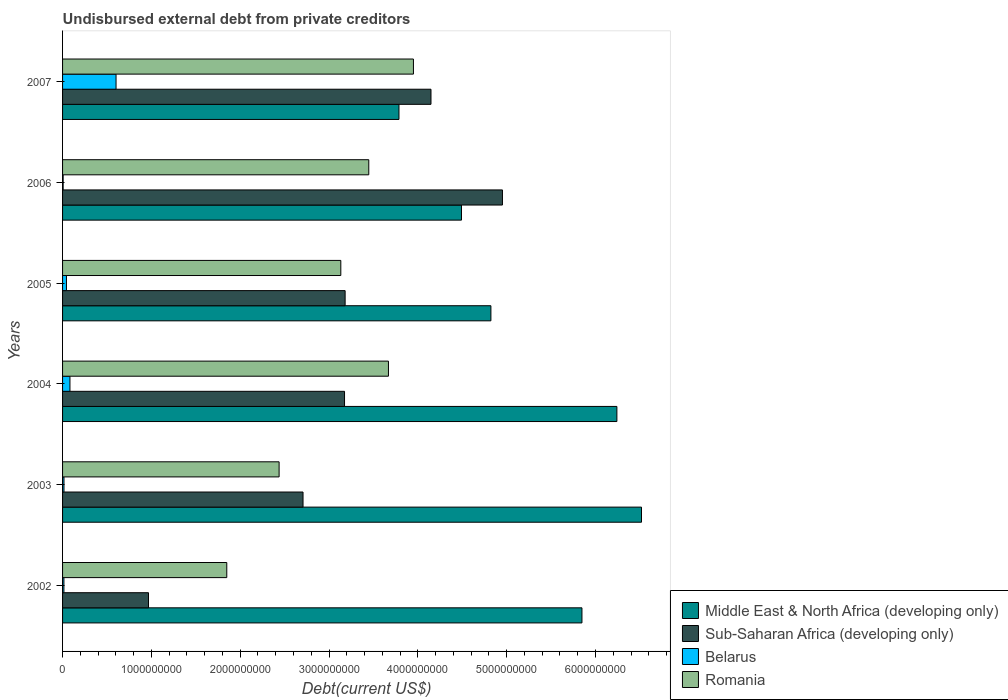How many different coloured bars are there?
Provide a succinct answer. 4. Are the number of bars on each tick of the Y-axis equal?
Provide a short and direct response. Yes. How many bars are there on the 6th tick from the top?
Your answer should be very brief. 4. What is the total debt in Romania in 2006?
Make the answer very short. 3.45e+09. Across all years, what is the maximum total debt in Romania?
Your answer should be compact. 3.95e+09. Across all years, what is the minimum total debt in Romania?
Offer a terse response. 1.85e+09. In which year was the total debt in Middle East & North Africa (developing only) maximum?
Your response must be concise. 2003. In which year was the total debt in Middle East & North Africa (developing only) minimum?
Your answer should be compact. 2007. What is the total total debt in Belarus in the graph?
Give a very brief answer. 7.67e+08. What is the difference between the total debt in Belarus in 2004 and that in 2006?
Provide a succinct answer. 7.65e+07. What is the difference between the total debt in Romania in 2004 and the total debt in Middle East & North Africa (developing only) in 2002?
Offer a very short reply. -2.18e+09. What is the average total debt in Middle East & North Africa (developing only) per year?
Your answer should be very brief. 5.28e+09. In the year 2002, what is the difference between the total debt in Romania and total debt in Middle East & North Africa (developing only)?
Ensure brevity in your answer.  -4.00e+09. What is the ratio of the total debt in Romania in 2003 to that in 2004?
Make the answer very short. 0.66. Is the difference between the total debt in Romania in 2002 and 2003 greater than the difference between the total debt in Middle East & North Africa (developing only) in 2002 and 2003?
Offer a terse response. Yes. What is the difference between the highest and the second highest total debt in Belarus?
Provide a succinct answer. 5.19e+08. What is the difference between the highest and the lowest total debt in Romania?
Make the answer very short. 2.10e+09. In how many years, is the total debt in Middle East & North Africa (developing only) greater than the average total debt in Middle East & North Africa (developing only) taken over all years?
Provide a succinct answer. 3. Is it the case that in every year, the sum of the total debt in Belarus and total debt in Middle East & North Africa (developing only) is greater than the sum of total debt in Romania and total debt in Sub-Saharan Africa (developing only)?
Your response must be concise. No. What does the 2nd bar from the top in 2007 represents?
Offer a very short reply. Belarus. What does the 2nd bar from the bottom in 2003 represents?
Make the answer very short. Sub-Saharan Africa (developing only). How many bars are there?
Provide a succinct answer. 24. Are all the bars in the graph horizontal?
Keep it short and to the point. Yes. Are the values on the major ticks of X-axis written in scientific E-notation?
Keep it short and to the point. No. Does the graph contain any zero values?
Make the answer very short. No. Does the graph contain grids?
Provide a succinct answer. No. Where does the legend appear in the graph?
Offer a terse response. Bottom right. How many legend labels are there?
Provide a short and direct response. 4. How are the legend labels stacked?
Keep it short and to the point. Vertical. What is the title of the graph?
Keep it short and to the point. Undisbursed external debt from private creditors. What is the label or title of the X-axis?
Provide a short and direct response. Debt(current US$). What is the Debt(current US$) in Middle East & North Africa (developing only) in 2002?
Make the answer very short. 5.85e+09. What is the Debt(current US$) of Sub-Saharan Africa (developing only) in 2002?
Provide a short and direct response. 9.67e+08. What is the Debt(current US$) in Belarus in 2002?
Keep it short and to the point. 1.54e+07. What is the Debt(current US$) of Romania in 2002?
Give a very brief answer. 1.85e+09. What is the Debt(current US$) in Middle East & North Africa (developing only) in 2003?
Provide a short and direct response. 6.52e+09. What is the Debt(current US$) of Sub-Saharan Africa (developing only) in 2003?
Give a very brief answer. 2.71e+09. What is the Debt(current US$) in Belarus in 2003?
Make the answer very short. 1.59e+07. What is the Debt(current US$) in Romania in 2003?
Offer a very short reply. 2.44e+09. What is the Debt(current US$) of Middle East & North Africa (developing only) in 2004?
Your answer should be very brief. 6.24e+09. What is the Debt(current US$) of Sub-Saharan Africa (developing only) in 2004?
Your answer should be very brief. 3.17e+09. What is the Debt(current US$) in Belarus in 2004?
Your answer should be compact. 8.32e+07. What is the Debt(current US$) in Romania in 2004?
Offer a terse response. 3.67e+09. What is the Debt(current US$) of Middle East & North Africa (developing only) in 2005?
Ensure brevity in your answer.  4.82e+09. What is the Debt(current US$) of Sub-Saharan Africa (developing only) in 2005?
Give a very brief answer. 3.18e+09. What is the Debt(current US$) in Belarus in 2005?
Provide a succinct answer. 4.38e+07. What is the Debt(current US$) of Romania in 2005?
Provide a short and direct response. 3.13e+09. What is the Debt(current US$) of Middle East & North Africa (developing only) in 2006?
Provide a short and direct response. 4.49e+09. What is the Debt(current US$) in Sub-Saharan Africa (developing only) in 2006?
Provide a succinct answer. 4.95e+09. What is the Debt(current US$) of Belarus in 2006?
Ensure brevity in your answer.  6.63e+06. What is the Debt(current US$) of Romania in 2006?
Give a very brief answer. 3.45e+09. What is the Debt(current US$) in Middle East & North Africa (developing only) in 2007?
Provide a short and direct response. 3.79e+09. What is the Debt(current US$) in Sub-Saharan Africa (developing only) in 2007?
Offer a very short reply. 4.15e+09. What is the Debt(current US$) of Belarus in 2007?
Provide a short and direct response. 6.02e+08. What is the Debt(current US$) in Romania in 2007?
Offer a very short reply. 3.95e+09. Across all years, what is the maximum Debt(current US$) in Middle East & North Africa (developing only)?
Provide a short and direct response. 6.52e+09. Across all years, what is the maximum Debt(current US$) of Sub-Saharan Africa (developing only)?
Offer a very short reply. 4.95e+09. Across all years, what is the maximum Debt(current US$) of Belarus?
Provide a short and direct response. 6.02e+08. Across all years, what is the maximum Debt(current US$) in Romania?
Give a very brief answer. 3.95e+09. Across all years, what is the minimum Debt(current US$) of Middle East & North Africa (developing only)?
Your response must be concise. 3.79e+09. Across all years, what is the minimum Debt(current US$) of Sub-Saharan Africa (developing only)?
Keep it short and to the point. 9.67e+08. Across all years, what is the minimum Debt(current US$) of Belarus?
Give a very brief answer. 6.63e+06. Across all years, what is the minimum Debt(current US$) of Romania?
Give a very brief answer. 1.85e+09. What is the total Debt(current US$) of Middle East & North Africa (developing only) in the graph?
Offer a very short reply. 3.17e+1. What is the total Debt(current US$) of Sub-Saharan Africa (developing only) in the graph?
Give a very brief answer. 1.91e+1. What is the total Debt(current US$) in Belarus in the graph?
Your answer should be compact. 7.67e+08. What is the total Debt(current US$) in Romania in the graph?
Your answer should be compact. 1.85e+1. What is the difference between the Debt(current US$) in Middle East & North Africa (developing only) in 2002 and that in 2003?
Your answer should be very brief. -6.70e+08. What is the difference between the Debt(current US$) of Sub-Saharan Africa (developing only) in 2002 and that in 2003?
Make the answer very short. -1.74e+09. What is the difference between the Debt(current US$) of Belarus in 2002 and that in 2003?
Keep it short and to the point. -5.75e+05. What is the difference between the Debt(current US$) of Romania in 2002 and that in 2003?
Give a very brief answer. -5.89e+08. What is the difference between the Debt(current US$) of Middle East & North Africa (developing only) in 2002 and that in 2004?
Keep it short and to the point. -3.93e+08. What is the difference between the Debt(current US$) in Sub-Saharan Africa (developing only) in 2002 and that in 2004?
Offer a very short reply. -2.21e+09. What is the difference between the Debt(current US$) in Belarus in 2002 and that in 2004?
Provide a short and direct response. -6.78e+07. What is the difference between the Debt(current US$) of Romania in 2002 and that in 2004?
Your response must be concise. -1.82e+09. What is the difference between the Debt(current US$) of Middle East & North Africa (developing only) in 2002 and that in 2005?
Offer a very short reply. 1.03e+09. What is the difference between the Debt(current US$) of Sub-Saharan Africa (developing only) in 2002 and that in 2005?
Your answer should be compact. -2.21e+09. What is the difference between the Debt(current US$) in Belarus in 2002 and that in 2005?
Your response must be concise. -2.85e+07. What is the difference between the Debt(current US$) of Romania in 2002 and that in 2005?
Offer a terse response. -1.28e+09. What is the difference between the Debt(current US$) in Middle East & North Africa (developing only) in 2002 and that in 2006?
Ensure brevity in your answer.  1.36e+09. What is the difference between the Debt(current US$) in Sub-Saharan Africa (developing only) in 2002 and that in 2006?
Give a very brief answer. -3.99e+09. What is the difference between the Debt(current US$) in Belarus in 2002 and that in 2006?
Offer a terse response. 8.72e+06. What is the difference between the Debt(current US$) of Romania in 2002 and that in 2006?
Ensure brevity in your answer.  -1.60e+09. What is the difference between the Debt(current US$) of Middle East & North Africa (developing only) in 2002 and that in 2007?
Keep it short and to the point. 2.06e+09. What is the difference between the Debt(current US$) in Sub-Saharan Africa (developing only) in 2002 and that in 2007?
Provide a succinct answer. -3.18e+09. What is the difference between the Debt(current US$) of Belarus in 2002 and that in 2007?
Your response must be concise. -5.87e+08. What is the difference between the Debt(current US$) in Romania in 2002 and that in 2007?
Provide a succinct answer. -2.10e+09. What is the difference between the Debt(current US$) in Middle East & North Africa (developing only) in 2003 and that in 2004?
Your answer should be compact. 2.77e+08. What is the difference between the Debt(current US$) in Sub-Saharan Africa (developing only) in 2003 and that in 2004?
Give a very brief answer. -4.67e+08. What is the difference between the Debt(current US$) of Belarus in 2003 and that in 2004?
Your answer should be very brief. -6.72e+07. What is the difference between the Debt(current US$) of Romania in 2003 and that in 2004?
Keep it short and to the point. -1.23e+09. What is the difference between the Debt(current US$) in Middle East & North Africa (developing only) in 2003 and that in 2005?
Your answer should be compact. 1.70e+09. What is the difference between the Debt(current US$) in Sub-Saharan Africa (developing only) in 2003 and that in 2005?
Give a very brief answer. -4.74e+08. What is the difference between the Debt(current US$) in Belarus in 2003 and that in 2005?
Keep it short and to the point. -2.79e+07. What is the difference between the Debt(current US$) of Romania in 2003 and that in 2005?
Offer a very short reply. -6.95e+08. What is the difference between the Debt(current US$) of Middle East & North Africa (developing only) in 2003 and that in 2006?
Keep it short and to the point. 2.03e+09. What is the difference between the Debt(current US$) of Sub-Saharan Africa (developing only) in 2003 and that in 2006?
Provide a short and direct response. -2.25e+09. What is the difference between the Debt(current US$) of Belarus in 2003 and that in 2006?
Offer a terse response. 9.30e+06. What is the difference between the Debt(current US$) in Romania in 2003 and that in 2006?
Your answer should be very brief. -1.01e+09. What is the difference between the Debt(current US$) in Middle East & North Africa (developing only) in 2003 and that in 2007?
Give a very brief answer. 2.73e+09. What is the difference between the Debt(current US$) of Sub-Saharan Africa (developing only) in 2003 and that in 2007?
Offer a very short reply. -1.44e+09. What is the difference between the Debt(current US$) in Belarus in 2003 and that in 2007?
Offer a very short reply. -5.86e+08. What is the difference between the Debt(current US$) in Romania in 2003 and that in 2007?
Your answer should be compact. -1.51e+09. What is the difference between the Debt(current US$) of Middle East & North Africa (developing only) in 2004 and that in 2005?
Provide a short and direct response. 1.42e+09. What is the difference between the Debt(current US$) in Sub-Saharan Africa (developing only) in 2004 and that in 2005?
Your answer should be very brief. -6.60e+06. What is the difference between the Debt(current US$) of Belarus in 2004 and that in 2005?
Keep it short and to the point. 3.93e+07. What is the difference between the Debt(current US$) of Romania in 2004 and that in 2005?
Your answer should be compact. 5.36e+08. What is the difference between the Debt(current US$) of Middle East & North Africa (developing only) in 2004 and that in 2006?
Ensure brevity in your answer.  1.75e+09. What is the difference between the Debt(current US$) of Sub-Saharan Africa (developing only) in 2004 and that in 2006?
Make the answer very short. -1.78e+09. What is the difference between the Debt(current US$) of Belarus in 2004 and that in 2006?
Provide a succinct answer. 7.65e+07. What is the difference between the Debt(current US$) of Romania in 2004 and that in 2006?
Provide a short and direct response. 2.21e+08. What is the difference between the Debt(current US$) in Middle East & North Africa (developing only) in 2004 and that in 2007?
Provide a succinct answer. 2.45e+09. What is the difference between the Debt(current US$) of Sub-Saharan Africa (developing only) in 2004 and that in 2007?
Keep it short and to the point. -9.73e+08. What is the difference between the Debt(current US$) of Belarus in 2004 and that in 2007?
Make the answer very short. -5.19e+08. What is the difference between the Debt(current US$) of Romania in 2004 and that in 2007?
Make the answer very short. -2.81e+08. What is the difference between the Debt(current US$) of Middle East & North Africa (developing only) in 2005 and that in 2006?
Your response must be concise. 3.31e+08. What is the difference between the Debt(current US$) in Sub-Saharan Africa (developing only) in 2005 and that in 2006?
Keep it short and to the point. -1.77e+09. What is the difference between the Debt(current US$) in Belarus in 2005 and that in 2006?
Ensure brevity in your answer.  3.72e+07. What is the difference between the Debt(current US$) of Romania in 2005 and that in 2006?
Offer a terse response. -3.15e+08. What is the difference between the Debt(current US$) of Middle East & North Africa (developing only) in 2005 and that in 2007?
Offer a terse response. 1.04e+09. What is the difference between the Debt(current US$) in Sub-Saharan Africa (developing only) in 2005 and that in 2007?
Ensure brevity in your answer.  -9.67e+08. What is the difference between the Debt(current US$) of Belarus in 2005 and that in 2007?
Your answer should be very brief. -5.58e+08. What is the difference between the Debt(current US$) in Romania in 2005 and that in 2007?
Your response must be concise. -8.18e+08. What is the difference between the Debt(current US$) in Middle East & North Africa (developing only) in 2006 and that in 2007?
Ensure brevity in your answer.  7.04e+08. What is the difference between the Debt(current US$) of Sub-Saharan Africa (developing only) in 2006 and that in 2007?
Give a very brief answer. 8.05e+08. What is the difference between the Debt(current US$) in Belarus in 2006 and that in 2007?
Make the answer very short. -5.95e+08. What is the difference between the Debt(current US$) of Romania in 2006 and that in 2007?
Keep it short and to the point. -5.03e+08. What is the difference between the Debt(current US$) of Middle East & North Africa (developing only) in 2002 and the Debt(current US$) of Sub-Saharan Africa (developing only) in 2003?
Make the answer very short. 3.14e+09. What is the difference between the Debt(current US$) of Middle East & North Africa (developing only) in 2002 and the Debt(current US$) of Belarus in 2003?
Keep it short and to the point. 5.83e+09. What is the difference between the Debt(current US$) of Middle East & North Africa (developing only) in 2002 and the Debt(current US$) of Romania in 2003?
Make the answer very short. 3.41e+09. What is the difference between the Debt(current US$) in Sub-Saharan Africa (developing only) in 2002 and the Debt(current US$) in Belarus in 2003?
Ensure brevity in your answer.  9.52e+08. What is the difference between the Debt(current US$) of Sub-Saharan Africa (developing only) in 2002 and the Debt(current US$) of Romania in 2003?
Provide a succinct answer. -1.47e+09. What is the difference between the Debt(current US$) in Belarus in 2002 and the Debt(current US$) in Romania in 2003?
Provide a succinct answer. -2.42e+09. What is the difference between the Debt(current US$) in Middle East & North Africa (developing only) in 2002 and the Debt(current US$) in Sub-Saharan Africa (developing only) in 2004?
Ensure brevity in your answer.  2.67e+09. What is the difference between the Debt(current US$) of Middle East & North Africa (developing only) in 2002 and the Debt(current US$) of Belarus in 2004?
Offer a terse response. 5.76e+09. What is the difference between the Debt(current US$) of Middle East & North Africa (developing only) in 2002 and the Debt(current US$) of Romania in 2004?
Give a very brief answer. 2.18e+09. What is the difference between the Debt(current US$) of Sub-Saharan Africa (developing only) in 2002 and the Debt(current US$) of Belarus in 2004?
Make the answer very short. 8.84e+08. What is the difference between the Debt(current US$) in Sub-Saharan Africa (developing only) in 2002 and the Debt(current US$) in Romania in 2004?
Offer a terse response. -2.70e+09. What is the difference between the Debt(current US$) of Belarus in 2002 and the Debt(current US$) of Romania in 2004?
Offer a very short reply. -3.65e+09. What is the difference between the Debt(current US$) in Middle East & North Africa (developing only) in 2002 and the Debt(current US$) in Sub-Saharan Africa (developing only) in 2005?
Provide a short and direct response. 2.67e+09. What is the difference between the Debt(current US$) of Middle East & North Africa (developing only) in 2002 and the Debt(current US$) of Belarus in 2005?
Keep it short and to the point. 5.80e+09. What is the difference between the Debt(current US$) of Middle East & North Africa (developing only) in 2002 and the Debt(current US$) of Romania in 2005?
Provide a succinct answer. 2.72e+09. What is the difference between the Debt(current US$) of Sub-Saharan Africa (developing only) in 2002 and the Debt(current US$) of Belarus in 2005?
Make the answer very short. 9.24e+08. What is the difference between the Debt(current US$) in Sub-Saharan Africa (developing only) in 2002 and the Debt(current US$) in Romania in 2005?
Give a very brief answer. -2.17e+09. What is the difference between the Debt(current US$) of Belarus in 2002 and the Debt(current US$) of Romania in 2005?
Your answer should be compact. -3.12e+09. What is the difference between the Debt(current US$) of Middle East & North Africa (developing only) in 2002 and the Debt(current US$) of Sub-Saharan Africa (developing only) in 2006?
Offer a very short reply. 8.95e+08. What is the difference between the Debt(current US$) in Middle East & North Africa (developing only) in 2002 and the Debt(current US$) in Belarus in 2006?
Your response must be concise. 5.84e+09. What is the difference between the Debt(current US$) in Middle East & North Africa (developing only) in 2002 and the Debt(current US$) in Romania in 2006?
Offer a terse response. 2.40e+09. What is the difference between the Debt(current US$) of Sub-Saharan Africa (developing only) in 2002 and the Debt(current US$) of Belarus in 2006?
Your answer should be compact. 9.61e+08. What is the difference between the Debt(current US$) of Sub-Saharan Africa (developing only) in 2002 and the Debt(current US$) of Romania in 2006?
Offer a terse response. -2.48e+09. What is the difference between the Debt(current US$) in Belarus in 2002 and the Debt(current US$) in Romania in 2006?
Make the answer very short. -3.43e+09. What is the difference between the Debt(current US$) of Middle East & North Africa (developing only) in 2002 and the Debt(current US$) of Sub-Saharan Africa (developing only) in 2007?
Keep it short and to the point. 1.70e+09. What is the difference between the Debt(current US$) in Middle East & North Africa (developing only) in 2002 and the Debt(current US$) in Belarus in 2007?
Ensure brevity in your answer.  5.25e+09. What is the difference between the Debt(current US$) of Middle East & North Africa (developing only) in 2002 and the Debt(current US$) of Romania in 2007?
Make the answer very short. 1.90e+09. What is the difference between the Debt(current US$) of Sub-Saharan Africa (developing only) in 2002 and the Debt(current US$) of Belarus in 2007?
Provide a succinct answer. 3.65e+08. What is the difference between the Debt(current US$) in Sub-Saharan Africa (developing only) in 2002 and the Debt(current US$) in Romania in 2007?
Your response must be concise. -2.98e+09. What is the difference between the Debt(current US$) in Belarus in 2002 and the Debt(current US$) in Romania in 2007?
Your answer should be very brief. -3.94e+09. What is the difference between the Debt(current US$) in Middle East & North Africa (developing only) in 2003 and the Debt(current US$) in Sub-Saharan Africa (developing only) in 2004?
Provide a short and direct response. 3.34e+09. What is the difference between the Debt(current US$) of Middle East & North Africa (developing only) in 2003 and the Debt(current US$) of Belarus in 2004?
Offer a terse response. 6.44e+09. What is the difference between the Debt(current US$) in Middle East & North Africa (developing only) in 2003 and the Debt(current US$) in Romania in 2004?
Your answer should be compact. 2.85e+09. What is the difference between the Debt(current US$) in Sub-Saharan Africa (developing only) in 2003 and the Debt(current US$) in Belarus in 2004?
Make the answer very short. 2.62e+09. What is the difference between the Debt(current US$) in Sub-Saharan Africa (developing only) in 2003 and the Debt(current US$) in Romania in 2004?
Your answer should be compact. -9.62e+08. What is the difference between the Debt(current US$) of Belarus in 2003 and the Debt(current US$) of Romania in 2004?
Provide a succinct answer. -3.65e+09. What is the difference between the Debt(current US$) of Middle East & North Africa (developing only) in 2003 and the Debt(current US$) of Sub-Saharan Africa (developing only) in 2005?
Your answer should be compact. 3.34e+09. What is the difference between the Debt(current US$) in Middle East & North Africa (developing only) in 2003 and the Debt(current US$) in Belarus in 2005?
Your response must be concise. 6.47e+09. What is the difference between the Debt(current US$) in Middle East & North Africa (developing only) in 2003 and the Debt(current US$) in Romania in 2005?
Offer a very short reply. 3.39e+09. What is the difference between the Debt(current US$) of Sub-Saharan Africa (developing only) in 2003 and the Debt(current US$) of Belarus in 2005?
Offer a terse response. 2.66e+09. What is the difference between the Debt(current US$) in Sub-Saharan Africa (developing only) in 2003 and the Debt(current US$) in Romania in 2005?
Ensure brevity in your answer.  -4.25e+08. What is the difference between the Debt(current US$) of Belarus in 2003 and the Debt(current US$) of Romania in 2005?
Offer a very short reply. -3.12e+09. What is the difference between the Debt(current US$) in Middle East & North Africa (developing only) in 2003 and the Debt(current US$) in Sub-Saharan Africa (developing only) in 2006?
Your response must be concise. 1.57e+09. What is the difference between the Debt(current US$) in Middle East & North Africa (developing only) in 2003 and the Debt(current US$) in Belarus in 2006?
Keep it short and to the point. 6.51e+09. What is the difference between the Debt(current US$) in Middle East & North Africa (developing only) in 2003 and the Debt(current US$) in Romania in 2006?
Ensure brevity in your answer.  3.07e+09. What is the difference between the Debt(current US$) of Sub-Saharan Africa (developing only) in 2003 and the Debt(current US$) of Belarus in 2006?
Your response must be concise. 2.70e+09. What is the difference between the Debt(current US$) of Sub-Saharan Africa (developing only) in 2003 and the Debt(current US$) of Romania in 2006?
Offer a very short reply. -7.40e+08. What is the difference between the Debt(current US$) in Belarus in 2003 and the Debt(current US$) in Romania in 2006?
Offer a terse response. -3.43e+09. What is the difference between the Debt(current US$) in Middle East & North Africa (developing only) in 2003 and the Debt(current US$) in Sub-Saharan Africa (developing only) in 2007?
Make the answer very short. 2.37e+09. What is the difference between the Debt(current US$) of Middle East & North Africa (developing only) in 2003 and the Debt(current US$) of Belarus in 2007?
Provide a succinct answer. 5.92e+09. What is the difference between the Debt(current US$) in Middle East & North Africa (developing only) in 2003 and the Debt(current US$) in Romania in 2007?
Keep it short and to the point. 2.57e+09. What is the difference between the Debt(current US$) of Sub-Saharan Africa (developing only) in 2003 and the Debt(current US$) of Belarus in 2007?
Make the answer very short. 2.11e+09. What is the difference between the Debt(current US$) of Sub-Saharan Africa (developing only) in 2003 and the Debt(current US$) of Romania in 2007?
Provide a short and direct response. -1.24e+09. What is the difference between the Debt(current US$) of Belarus in 2003 and the Debt(current US$) of Romania in 2007?
Make the answer very short. -3.93e+09. What is the difference between the Debt(current US$) of Middle East & North Africa (developing only) in 2004 and the Debt(current US$) of Sub-Saharan Africa (developing only) in 2005?
Provide a short and direct response. 3.06e+09. What is the difference between the Debt(current US$) of Middle East & North Africa (developing only) in 2004 and the Debt(current US$) of Belarus in 2005?
Your answer should be compact. 6.20e+09. What is the difference between the Debt(current US$) in Middle East & North Africa (developing only) in 2004 and the Debt(current US$) in Romania in 2005?
Offer a terse response. 3.11e+09. What is the difference between the Debt(current US$) of Sub-Saharan Africa (developing only) in 2004 and the Debt(current US$) of Belarus in 2005?
Give a very brief answer. 3.13e+09. What is the difference between the Debt(current US$) of Sub-Saharan Africa (developing only) in 2004 and the Debt(current US$) of Romania in 2005?
Give a very brief answer. 4.19e+07. What is the difference between the Debt(current US$) of Belarus in 2004 and the Debt(current US$) of Romania in 2005?
Make the answer very short. -3.05e+09. What is the difference between the Debt(current US$) in Middle East & North Africa (developing only) in 2004 and the Debt(current US$) in Sub-Saharan Africa (developing only) in 2006?
Offer a terse response. 1.29e+09. What is the difference between the Debt(current US$) in Middle East & North Africa (developing only) in 2004 and the Debt(current US$) in Belarus in 2006?
Provide a short and direct response. 6.23e+09. What is the difference between the Debt(current US$) in Middle East & North Africa (developing only) in 2004 and the Debt(current US$) in Romania in 2006?
Give a very brief answer. 2.79e+09. What is the difference between the Debt(current US$) in Sub-Saharan Africa (developing only) in 2004 and the Debt(current US$) in Belarus in 2006?
Your answer should be compact. 3.17e+09. What is the difference between the Debt(current US$) of Sub-Saharan Africa (developing only) in 2004 and the Debt(current US$) of Romania in 2006?
Provide a short and direct response. -2.73e+08. What is the difference between the Debt(current US$) of Belarus in 2004 and the Debt(current US$) of Romania in 2006?
Give a very brief answer. -3.36e+09. What is the difference between the Debt(current US$) in Middle East & North Africa (developing only) in 2004 and the Debt(current US$) in Sub-Saharan Africa (developing only) in 2007?
Keep it short and to the point. 2.09e+09. What is the difference between the Debt(current US$) of Middle East & North Africa (developing only) in 2004 and the Debt(current US$) of Belarus in 2007?
Your answer should be very brief. 5.64e+09. What is the difference between the Debt(current US$) of Middle East & North Africa (developing only) in 2004 and the Debt(current US$) of Romania in 2007?
Provide a short and direct response. 2.29e+09. What is the difference between the Debt(current US$) in Sub-Saharan Africa (developing only) in 2004 and the Debt(current US$) in Belarus in 2007?
Offer a terse response. 2.57e+09. What is the difference between the Debt(current US$) in Sub-Saharan Africa (developing only) in 2004 and the Debt(current US$) in Romania in 2007?
Make the answer very short. -7.76e+08. What is the difference between the Debt(current US$) in Belarus in 2004 and the Debt(current US$) in Romania in 2007?
Offer a terse response. -3.87e+09. What is the difference between the Debt(current US$) in Middle East & North Africa (developing only) in 2005 and the Debt(current US$) in Sub-Saharan Africa (developing only) in 2006?
Provide a short and direct response. -1.30e+08. What is the difference between the Debt(current US$) of Middle East & North Africa (developing only) in 2005 and the Debt(current US$) of Belarus in 2006?
Your answer should be very brief. 4.82e+09. What is the difference between the Debt(current US$) of Middle East & North Africa (developing only) in 2005 and the Debt(current US$) of Romania in 2006?
Your answer should be very brief. 1.38e+09. What is the difference between the Debt(current US$) in Sub-Saharan Africa (developing only) in 2005 and the Debt(current US$) in Belarus in 2006?
Ensure brevity in your answer.  3.17e+09. What is the difference between the Debt(current US$) in Sub-Saharan Africa (developing only) in 2005 and the Debt(current US$) in Romania in 2006?
Provide a succinct answer. -2.66e+08. What is the difference between the Debt(current US$) in Belarus in 2005 and the Debt(current US$) in Romania in 2006?
Offer a very short reply. -3.40e+09. What is the difference between the Debt(current US$) of Middle East & North Africa (developing only) in 2005 and the Debt(current US$) of Sub-Saharan Africa (developing only) in 2007?
Make the answer very short. 6.75e+08. What is the difference between the Debt(current US$) of Middle East & North Africa (developing only) in 2005 and the Debt(current US$) of Belarus in 2007?
Give a very brief answer. 4.22e+09. What is the difference between the Debt(current US$) in Middle East & North Africa (developing only) in 2005 and the Debt(current US$) in Romania in 2007?
Offer a very short reply. 8.72e+08. What is the difference between the Debt(current US$) in Sub-Saharan Africa (developing only) in 2005 and the Debt(current US$) in Belarus in 2007?
Provide a short and direct response. 2.58e+09. What is the difference between the Debt(current US$) in Sub-Saharan Africa (developing only) in 2005 and the Debt(current US$) in Romania in 2007?
Offer a very short reply. -7.69e+08. What is the difference between the Debt(current US$) of Belarus in 2005 and the Debt(current US$) of Romania in 2007?
Provide a succinct answer. -3.91e+09. What is the difference between the Debt(current US$) in Middle East & North Africa (developing only) in 2006 and the Debt(current US$) in Sub-Saharan Africa (developing only) in 2007?
Give a very brief answer. 3.43e+08. What is the difference between the Debt(current US$) in Middle East & North Africa (developing only) in 2006 and the Debt(current US$) in Belarus in 2007?
Give a very brief answer. 3.89e+09. What is the difference between the Debt(current US$) of Middle East & North Africa (developing only) in 2006 and the Debt(current US$) of Romania in 2007?
Your answer should be compact. 5.41e+08. What is the difference between the Debt(current US$) in Sub-Saharan Africa (developing only) in 2006 and the Debt(current US$) in Belarus in 2007?
Offer a very short reply. 4.35e+09. What is the difference between the Debt(current US$) of Sub-Saharan Africa (developing only) in 2006 and the Debt(current US$) of Romania in 2007?
Your answer should be very brief. 1.00e+09. What is the difference between the Debt(current US$) in Belarus in 2006 and the Debt(current US$) in Romania in 2007?
Provide a succinct answer. -3.94e+09. What is the average Debt(current US$) of Middle East & North Africa (developing only) per year?
Your response must be concise. 5.28e+09. What is the average Debt(current US$) in Sub-Saharan Africa (developing only) per year?
Offer a very short reply. 3.19e+09. What is the average Debt(current US$) of Belarus per year?
Give a very brief answer. 1.28e+08. What is the average Debt(current US$) in Romania per year?
Make the answer very short. 3.08e+09. In the year 2002, what is the difference between the Debt(current US$) of Middle East & North Africa (developing only) and Debt(current US$) of Sub-Saharan Africa (developing only)?
Provide a short and direct response. 4.88e+09. In the year 2002, what is the difference between the Debt(current US$) of Middle East & North Africa (developing only) and Debt(current US$) of Belarus?
Ensure brevity in your answer.  5.83e+09. In the year 2002, what is the difference between the Debt(current US$) in Middle East & North Africa (developing only) and Debt(current US$) in Romania?
Your answer should be very brief. 4.00e+09. In the year 2002, what is the difference between the Debt(current US$) of Sub-Saharan Africa (developing only) and Debt(current US$) of Belarus?
Provide a succinct answer. 9.52e+08. In the year 2002, what is the difference between the Debt(current US$) in Sub-Saharan Africa (developing only) and Debt(current US$) in Romania?
Offer a terse response. -8.81e+08. In the year 2002, what is the difference between the Debt(current US$) of Belarus and Debt(current US$) of Romania?
Give a very brief answer. -1.83e+09. In the year 2003, what is the difference between the Debt(current US$) of Middle East & North Africa (developing only) and Debt(current US$) of Sub-Saharan Africa (developing only)?
Offer a terse response. 3.81e+09. In the year 2003, what is the difference between the Debt(current US$) of Middle East & North Africa (developing only) and Debt(current US$) of Belarus?
Your response must be concise. 6.50e+09. In the year 2003, what is the difference between the Debt(current US$) in Middle East & North Africa (developing only) and Debt(current US$) in Romania?
Make the answer very short. 4.08e+09. In the year 2003, what is the difference between the Debt(current US$) of Sub-Saharan Africa (developing only) and Debt(current US$) of Belarus?
Provide a short and direct response. 2.69e+09. In the year 2003, what is the difference between the Debt(current US$) of Sub-Saharan Africa (developing only) and Debt(current US$) of Romania?
Your answer should be very brief. 2.69e+08. In the year 2003, what is the difference between the Debt(current US$) of Belarus and Debt(current US$) of Romania?
Ensure brevity in your answer.  -2.42e+09. In the year 2004, what is the difference between the Debt(current US$) of Middle East & North Africa (developing only) and Debt(current US$) of Sub-Saharan Africa (developing only)?
Your answer should be compact. 3.07e+09. In the year 2004, what is the difference between the Debt(current US$) in Middle East & North Africa (developing only) and Debt(current US$) in Belarus?
Make the answer very short. 6.16e+09. In the year 2004, what is the difference between the Debt(current US$) in Middle East & North Africa (developing only) and Debt(current US$) in Romania?
Offer a terse response. 2.57e+09. In the year 2004, what is the difference between the Debt(current US$) in Sub-Saharan Africa (developing only) and Debt(current US$) in Belarus?
Your response must be concise. 3.09e+09. In the year 2004, what is the difference between the Debt(current US$) in Sub-Saharan Africa (developing only) and Debt(current US$) in Romania?
Give a very brief answer. -4.94e+08. In the year 2004, what is the difference between the Debt(current US$) in Belarus and Debt(current US$) in Romania?
Make the answer very short. -3.59e+09. In the year 2005, what is the difference between the Debt(current US$) of Middle East & North Africa (developing only) and Debt(current US$) of Sub-Saharan Africa (developing only)?
Give a very brief answer. 1.64e+09. In the year 2005, what is the difference between the Debt(current US$) in Middle East & North Africa (developing only) and Debt(current US$) in Belarus?
Give a very brief answer. 4.78e+09. In the year 2005, what is the difference between the Debt(current US$) of Middle East & North Africa (developing only) and Debt(current US$) of Romania?
Your response must be concise. 1.69e+09. In the year 2005, what is the difference between the Debt(current US$) in Sub-Saharan Africa (developing only) and Debt(current US$) in Belarus?
Make the answer very short. 3.14e+09. In the year 2005, what is the difference between the Debt(current US$) in Sub-Saharan Africa (developing only) and Debt(current US$) in Romania?
Offer a terse response. 4.85e+07. In the year 2005, what is the difference between the Debt(current US$) in Belarus and Debt(current US$) in Romania?
Provide a succinct answer. -3.09e+09. In the year 2006, what is the difference between the Debt(current US$) of Middle East & North Africa (developing only) and Debt(current US$) of Sub-Saharan Africa (developing only)?
Provide a short and direct response. -4.61e+08. In the year 2006, what is the difference between the Debt(current US$) in Middle East & North Africa (developing only) and Debt(current US$) in Belarus?
Ensure brevity in your answer.  4.48e+09. In the year 2006, what is the difference between the Debt(current US$) of Middle East & North Africa (developing only) and Debt(current US$) of Romania?
Give a very brief answer. 1.04e+09. In the year 2006, what is the difference between the Debt(current US$) of Sub-Saharan Africa (developing only) and Debt(current US$) of Belarus?
Provide a short and direct response. 4.95e+09. In the year 2006, what is the difference between the Debt(current US$) in Sub-Saharan Africa (developing only) and Debt(current US$) in Romania?
Make the answer very short. 1.50e+09. In the year 2006, what is the difference between the Debt(current US$) in Belarus and Debt(current US$) in Romania?
Offer a terse response. -3.44e+09. In the year 2007, what is the difference between the Debt(current US$) of Middle East & North Africa (developing only) and Debt(current US$) of Sub-Saharan Africa (developing only)?
Make the answer very short. -3.60e+08. In the year 2007, what is the difference between the Debt(current US$) in Middle East & North Africa (developing only) and Debt(current US$) in Belarus?
Offer a very short reply. 3.19e+09. In the year 2007, what is the difference between the Debt(current US$) in Middle East & North Africa (developing only) and Debt(current US$) in Romania?
Provide a short and direct response. -1.63e+08. In the year 2007, what is the difference between the Debt(current US$) in Sub-Saharan Africa (developing only) and Debt(current US$) in Belarus?
Provide a succinct answer. 3.55e+09. In the year 2007, what is the difference between the Debt(current US$) in Sub-Saharan Africa (developing only) and Debt(current US$) in Romania?
Offer a terse response. 1.97e+08. In the year 2007, what is the difference between the Debt(current US$) of Belarus and Debt(current US$) of Romania?
Ensure brevity in your answer.  -3.35e+09. What is the ratio of the Debt(current US$) in Middle East & North Africa (developing only) in 2002 to that in 2003?
Offer a terse response. 0.9. What is the ratio of the Debt(current US$) in Sub-Saharan Africa (developing only) in 2002 to that in 2003?
Make the answer very short. 0.36. What is the ratio of the Debt(current US$) in Belarus in 2002 to that in 2003?
Offer a terse response. 0.96. What is the ratio of the Debt(current US$) in Romania in 2002 to that in 2003?
Make the answer very short. 0.76. What is the ratio of the Debt(current US$) in Middle East & North Africa (developing only) in 2002 to that in 2004?
Your response must be concise. 0.94. What is the ratio of the Debt(current US$) in Sub-Saharan Africa (developing only) in 2002 to that in 2004?
Provide a short and direct response. 0.3. What is the ratio of the Debt(current US$) of Belarus in 2002 to that in 2004?
Your response must be concise. 0.18. What is the ratio of the Debt(current US$) of Romania in 2002 to that in 2004?
Offer a very short reply. 0.5. What is the ratio of the Debt(current US$) of Middle East & North Africa (developing only) in 2002 to that in 2005?
Offer a terse response. 1.21. What is the ratio of the Debt(current US$) of Sub-Saharan Africa (developing only) in 2002 to that in 2005?
Your answer should be compact. 0.3. What is the ratio of the Debt(current US$) in Belarus in 2002 to that in 2005?
Give a very brief answer. 0.35. What is the ratio of the Debt(current US$) of Romania in 2002 to that in 2005?
Your answer should be compact. 0.59. What is the ratio of the Debt(current US$) of Middle East & North Africa (developing only) in 2002 to that in 2006?
Your response must be concise. 1.3. What is the ratio of the Debt(current US$) of Sub-Saharan Africa (developing only) in 2002 to that in 2006?
Offer a very short reply. 0.2. What is the ratio of the Debt(current US$) in Belarus in 2002 to that in 2006?
Offer a very short reply. 2.32. What is the ratio of the Debt(current US$) in Romania in 2002 to that in 2006?
Make the answer very short. 0.54. What is the ratio of the Debt(current US$) in Middle East & North Africa (developing only) in 2002 to that in 2007?
Provide a succinct answer. 1.54. What is the ratio of the Debt(current US$) in Sub-Saharan Africa (developing only) in 2002 to that in 2007?
Your answer should be compact. 0.23. What is the ratio of the Debt(current US$) in Belarus in 2002 to that in 2007?
Provide a short and direct response. 0.03. What is the ratio of the Debt(current US$) of Romania in 2002 to that in 2007?
Keep it short and to the point. 0.47. What is the ratio of the Debt(current US$) in Middle East & North Africa (developing only) in 2003 to that in 2004?
Give a very brief answer. 1.04. What is the ratio of the Debt(current US$) in Sub-Saharan Africa (developing only) in 2003 to that in 2004?
Offer a very short reply. 0.85. What is the ratio of the Debt(current US$) in Belarus in 2003 to that in 2004?
Give a very brief answer. 0.19. What is the ratio of the Debt(current US$) of Romania in 2003 to that in 2004?
Your response must be concise. 0.66. What is the ratio of the Debt(current US$) in Middle East & North Africa (developing only) in 2003 to that in 2005?
Provide a short and direct response. 1.35. What is the ratio of the Debt(current US$) in Sub-Saharan Africa (developing only) in 2003 to that in 2005?
Make the answer very short. 0.85. What is the ratio of the Debt(current US$) of Belarus in 2003 to that in 2005?
Provide a short and direct response. 0.36. What is the ratio of the Debt(current US$) of Romania in 2003 to that in 2005?
Your answer should be very brief. 0.78. What is the ratio of the Debt(current US$) in Middle East & North Africa (developing only) in 2003 to that in 2006?
Your answer should be very brief. 1.45. What is the ratio of the Debt(current US$) in Sub-Saharan Africa (developing only) in 2003 to that in 2006?
Offer a very short reply. 0.55. What is the ratio of the Debt(current US$) in Belarus in 2003 to that in 2006?
Give a very brief answer. 2.4. What is the ratio of the Debt(current US$) in Romania in 2003 to that in 2006?
Keep it short and to the point. 0.71. What is the ratio of the Debt(current US$) of Middle East & North Africa (developing only) in 2003 to that in 2007?
Your response must be concise. 1.72. What is the ratio of the Debt(current US$) in Sub-Saharan Africa (developing only) in 2003 to that in 2007?
Make the answer very short. 0.65. What is the ratio of the Debt(current US$) of Belarus in 2003 to that in 2007?
Provide a short and direct response. 0.03. What is the ratio of the Debt(current US$) in Romania in 2003 to that in 2007?
Your answer should be compact. 0.62. What is the ratio of the Debt(current US$) in Middle East & North Africa (developing only) in 2004 to that in 2005?
Make the answer very short. 1.29. What is the ratio of the Debt(current US$) of Sub-Saharan Africa (developing only) in 2004 to that in 2005?
Offer a very short reply. 1. What is the ratio of the Debt(current US$) in Belarus in 2004 to that in 2005?
Offer a very short reply. 1.9. What is the ratio of the Debt(current US$) of Romania in 2004 to that in 2005?
Offer a very short reply. 1.17. What is the ratio of the Debt(current US$) of Middle East & North Africa (developing only) in 2004 to that in 2006?
Provide a short and direct response. 1.39. What is the ratio of the Debt(current US$) of Sub-Saharan Africa (developing only) in 2004 to that in 2006?
Ensure brevity in your answer.  0.64. What is the ratio of the Debt(current US$) in Belarus in 2004 to that in 2006?
Provide a short and direct response. 12.55. What is the ratio of the Debt(current US$) of Romania in 2004 to that in 2006?
Give a very brief answer. 1.06. What is the ratio of the Debt(current US$) in Middle East & North Africa (developing only) in 2004 to that in 2007?
Your answer should be very brief. 1.65. What is the ratio of the Debt(current US$) of Sub-Saharan Africa (developing only) in 2004 to that in 2007?
Offer a very short reply. 0.77. What is the ratio of the Debt(current US$) in Belarus in 2004 to that in 2007?
Offer a terse response. 0.14. What is the ratio of the Debt(current US$) of Romania in 2004 to that in 2007?
Offer a very short reply. 0.93. What is the ratio of the Debt(current US$) of Middle East & North Africa (developing only) in 2005 to that in 2006?
Your response must be concise. 1.07. What is the ratio of the Debt(current US$) of Sub-Saharan Africa (developing only) in 2005 to that in 2006?
Keep it short and to the point. 0.64. What is the ratio of the Debt(current US$) of Belarus in 2005 to that in 2006?
Make the answer very short. 6.61. What is the ratio of the Debt(current US$) of Romania in 2005 to that in 2006?
Your answer should be very brief. 0.91. What is the ratio of the Debt(current US$) in Middle East & North Africa (developing only) in 2005 to that in 2007?
Offer a terse response. 1.27. What is the ratio of the Debt(current US$) in Sub-Saharan Africa (developing only) in 2005 to that in 2007?
Provide a short and direct response. 0.77. What is the ratio of the Debt(current US$) of Belarus in 2005 to that in 2007?
Make the answer very short. 0.07. What is the ratio of the Debt(current US$) of Romania in 2005 to that in 2007?
Provide a succinct answer. 0.79. What is the ratio of the Debt(current US$) of Middle East & North Africa (developing only) in 2006 to that in 2007?
Provide a short and direct response. 1.19. What is the ratio of the Debt(current US$) in Sub-Saharan Africa (developing only) in 2006 to that in 2007?
Give a very brief answer. 1.19. What is the ratio of the Debt(current US$) of Belarus in 2006 to that in 2007?
Provide a short and direct response. 0.01. What is the ratio of the Debt(current US$) of Romania in 2006 to that in 2007?
Give a very brief answer. 0.87. What is the difference between the highest and the second highest Debt(current US$) in Middle East & North Africa (developing only)?
Your answer should be very brief. 2.77e+08. What is the difference between the highest and the second highest Debt(current US$) in Sub-Saharan Africa (developing only)?
Provide a succinct answer. 8.05e+08. What is the difference between the highest and the second highest Debt(current US$) in Belarus?
Provide a succinct answer. 5.19e+08. What is the difference between the highest and the second highest Debt(current US$) in Romania?
Offer a terse response. 2.81e+08. What is the difference between the highest and the lowest Debt(current US$) of Middle East & North Africa (developing only)?
Your answer should be very brief. 2.73e+09. What is the difference between the highest and the lowest Debt(current US$) in Sub-Saharan Africa (developing only)?
Your answer should be compact. 3.99e+09. What is the difference between the highest and the lowest Debt(current US$) in Belarus?
Your response must be concise. 5.95e+08. What is the difference between the highest and the lowest Debt(current US$) of Romania?
Provide a succinct answer. 2.10e+09. 